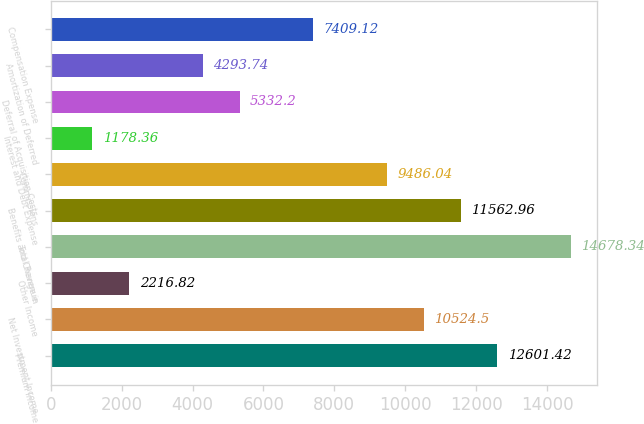<chart> <loc_0><loc_0><loc_500><loc_500><bar_chart><fcel>Premium Income<fcel>Net Investment Income<fcel>Other Income<fcel>Total Revenue<fcel>Benefits and Change in<fcel>Commissions<fcel>Interest and Debt Expense<fcel>Deferral of Acquisition Costs<fcel>Amortization of Deferred<fcel>Compensation Expense<nl><fcel>12601.4<fcel>10524.5<fcel>2216.82<fcel>14678.3<fcel>11563<fcel>9486.04<fcel>1178.36<fcel>5332.2<fcel>4293.74<fcel>7409.12<nl></chart> 